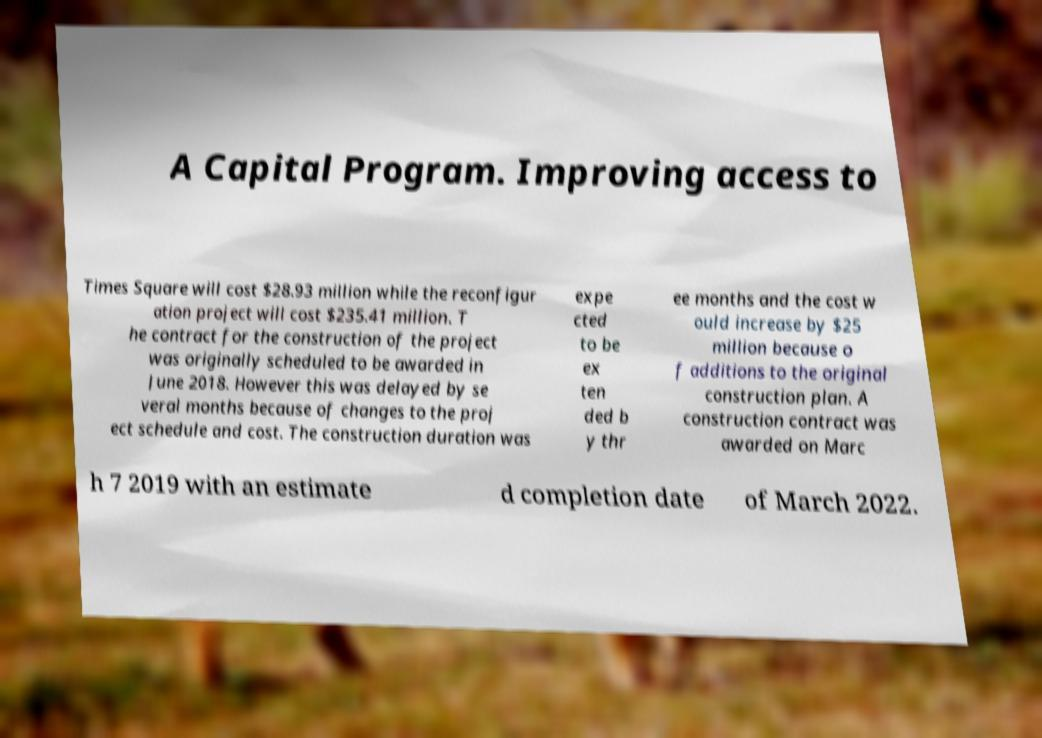Can you read and provide the text displayed in the image?This photo seems to have some interesting text. Can you extract and type it out for me? A Capital Program. Improving access to Times Square will cost $28.93 million while the reconfigur ation project will cost $235.41 million. T he contract for the construction of the project was originally scheduled to be awarded in June 2018. However this was delayed by se veral months because of changes to the proj ect schedule and cost. The construction duration was expe cted to be ex ten ded b y thr ee months and the cost w ould increase by $25 million because o f additions to the original construction plan. A construction contract was awarded on Marc h 7 2019 with an estimate d completion date of March 2022. 